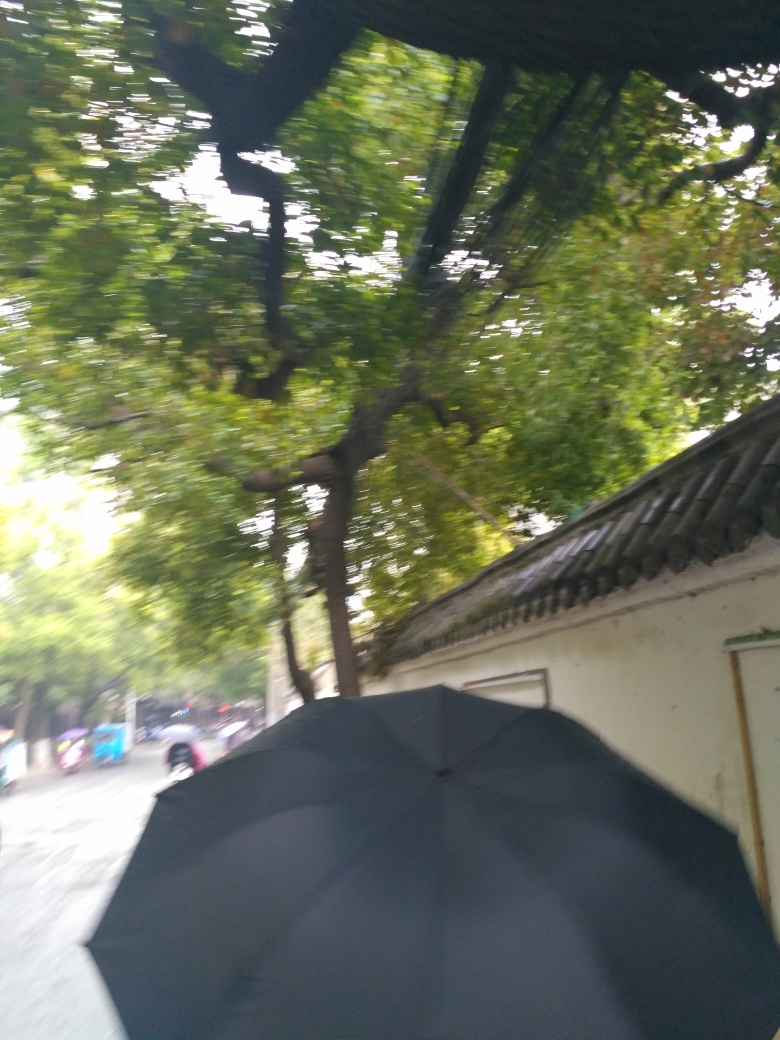Is there any noise in the image? Indeed, the image displays a significant amount of visual noise, characterized by the blur and graininess. This effect suggests the photo was taken with a rapid movement, potentially due to a shaky hand or by capturing a fast-moving scene without a sufficiently fast shutter speed. 